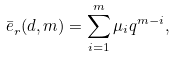Convert formula to latex. <formula><loc_0><loc_0><loc_500><loc_500>\bar { e } ^ { \AA } _ { r } ( d , m ) = \sum _ { i = 1 } ^ { m } \mu _ { i } q ^ { m - i } ,</formula> 